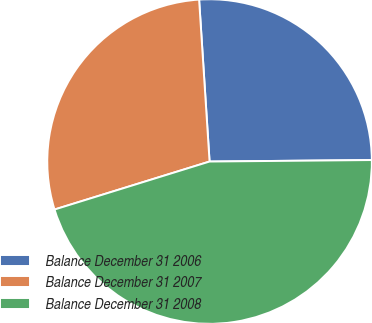Convert chart. <chart><loc_0><loc_0><loc_500><loc_500><pie_chart><fcel>Balance December 31 2006<fcel>Balance December 31 2007<fcel>Balance December 31 2008<nl><fcel>25.88%<fcel>28.75%<fcel>45.37%<nl></chart> 